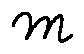Convert formula to latex. <formula><loc_0><loc_0><loc_500><loc_500>m</formula> 